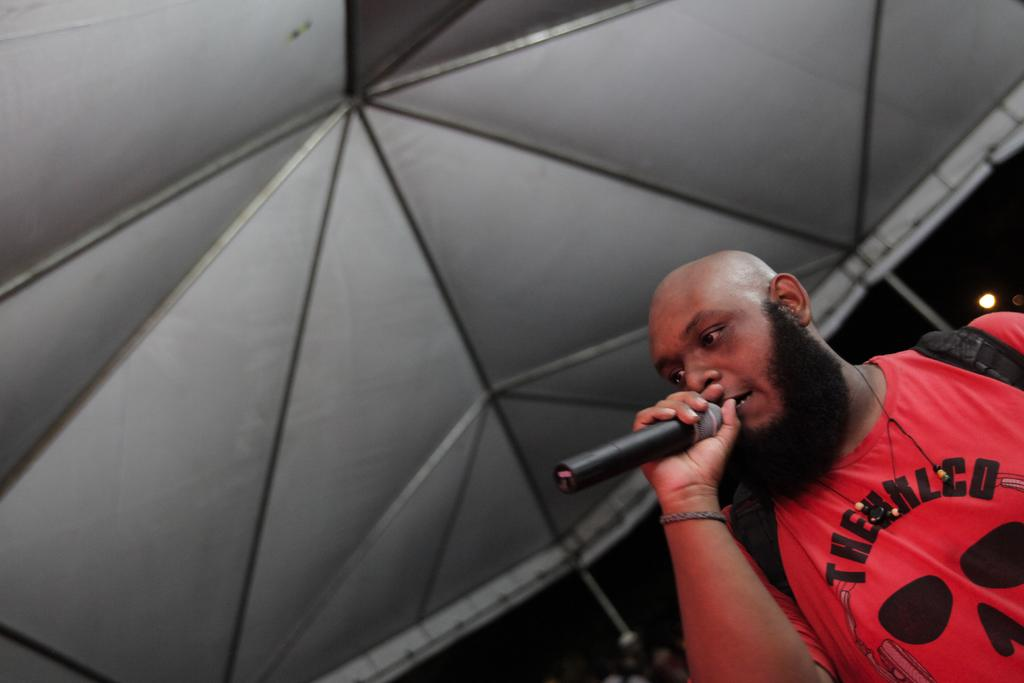What is the main subject of the image? There is a man in the image. What is the man holding in his hand? The man is holding a mic with his hand. Is the man carrying anything else in the image? Yes, the man is carrying a bag. What can be seen in the background of the man? There is a tent and a light in the background of the image. What type of bird is singing in the morning in the image? There is no bird or indication of morning in the image; it features a man holding a mic and carrying a bag. 